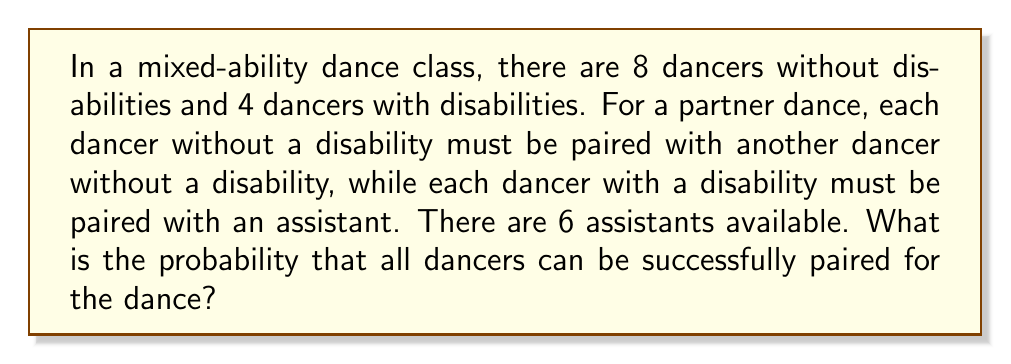Could you help me with this problem? Let's approach this step-by-step:

1) First, we need to pair the dancers without disabilities:
   - There are 8 dancers without disabilities to be paired among themselves
   - The number of ways to pair 8 people is:
     $$ \frac{8!}{(2!)^4 \cdot 4!} = 105 $$

2) Next, we need to pair the dancers with disabilities with assistants:
   - There are 4 dancers with disabilities and 6 assistants
   - This is a straightforward permutation problem:
     $$ P(6,4) = \frac{6!}{(6-4)!} = 360 $$

3) The total number of possible pairings is the product of these two results:
   $$ 105 \cdot 360 = 37,800 $$

4) This is also the number of successful pairings, as all dancers can be paired in each of these scenarios.

5) The total number of possible ways to attempt pairing (including unsuccessful attempts) is:
   - Pairing 8 dancers without disabilities: $\frac{8!}{(2!)^4} = 2,520$
   - Pairing 4 dancers with disabilities with 6 assistants: $6^4 = 1,296$
   $$ 2,520 \cdot 1,296 = 3,265,920 $$

6) Therefore, the probability of successful pairing is:
   $$ \frac{37,800}{3,265,920} = \frac{105}{9,072} \approx 0.0116 $$
Answer: $\frac{105}{9,072}$ 